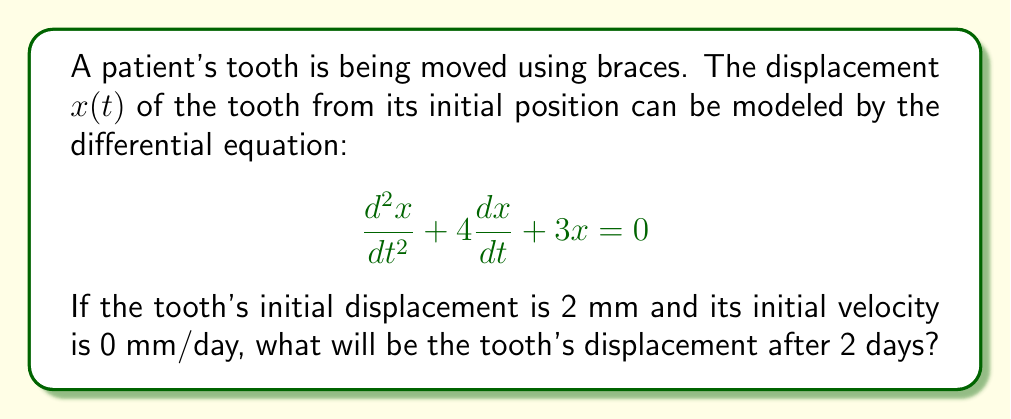Solve this math problem. To solve this problem, we need to follow these steps:

1) The given differential equation is a second-order linear homogeneous equation with constant coefficients. Its characteristic equation is:

   $$r^2 + 4r + 3 = 0$$

2) Solving this quadratic equation:
   $$(r + 1)(r + 3) = 0$$
   $$r = -1 \text{ or } r = -3$$

3) The general solution is therefore:

   $$x(t) = C_1e^{-t} + C_2e^{-3t}$$

4) We need to use the initial conditions to find $C_1$ and $C_2$:
   
   At $t = 0$, $x(0) = 2$ and $x'(0) = 0$

5) Using $x(0) = 2$:
   $$2 = C_1 + C_2$$

6) Using $x'(0) = 0$:
   $$x'(t) = -C_1e^{-t} - 3C_2e^{-3t}$$
   $$0 = -C_1 - 3C_2$$

7) Solving these simultaneous equations:
   $$C_1 = 3, C_2 = -1$$

8) Therefore, the particular solution is:

   $$x(t) = 3e^{-t} - e^{-3t}$$

9) To find the displacement after 2 days, we calculate $x(2)$:

   $$x(2) = 3e^{-2} - e^{-6}$$

10) Using a calculator or computer:

    $$x(2) \approx 0.4060 - 0.0025 \approx 0.4035 \text{ mm}$$
Answer: 0.4035 mm 